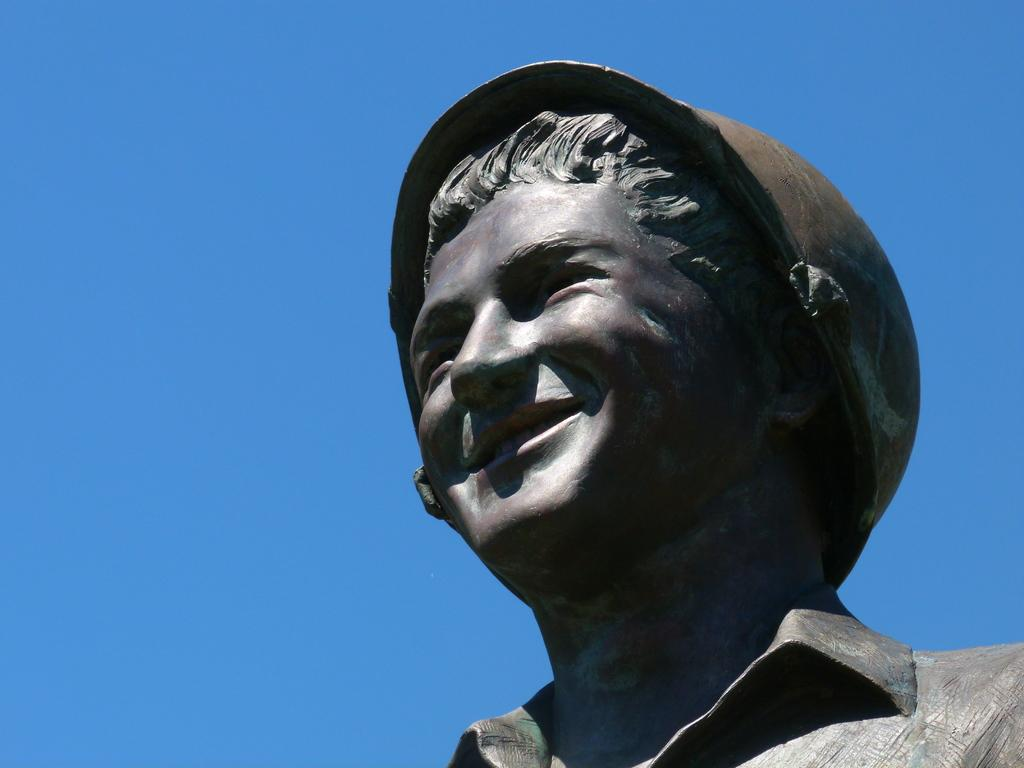What is the main subject of the image? The main subject of the image is a statue of a person. What is the statue doing or expressing? The statue is of a person who is smiling. What is visible at the top of the image? The sky is visible at the top of the image. What type of underwear is the statue wearing in the image? The statue is not a real person, so it is not wearing any underwear. What type of writing instrument is the statue holding in the image? The statue is not holding any writing instrument, such as a quill, in the image. 